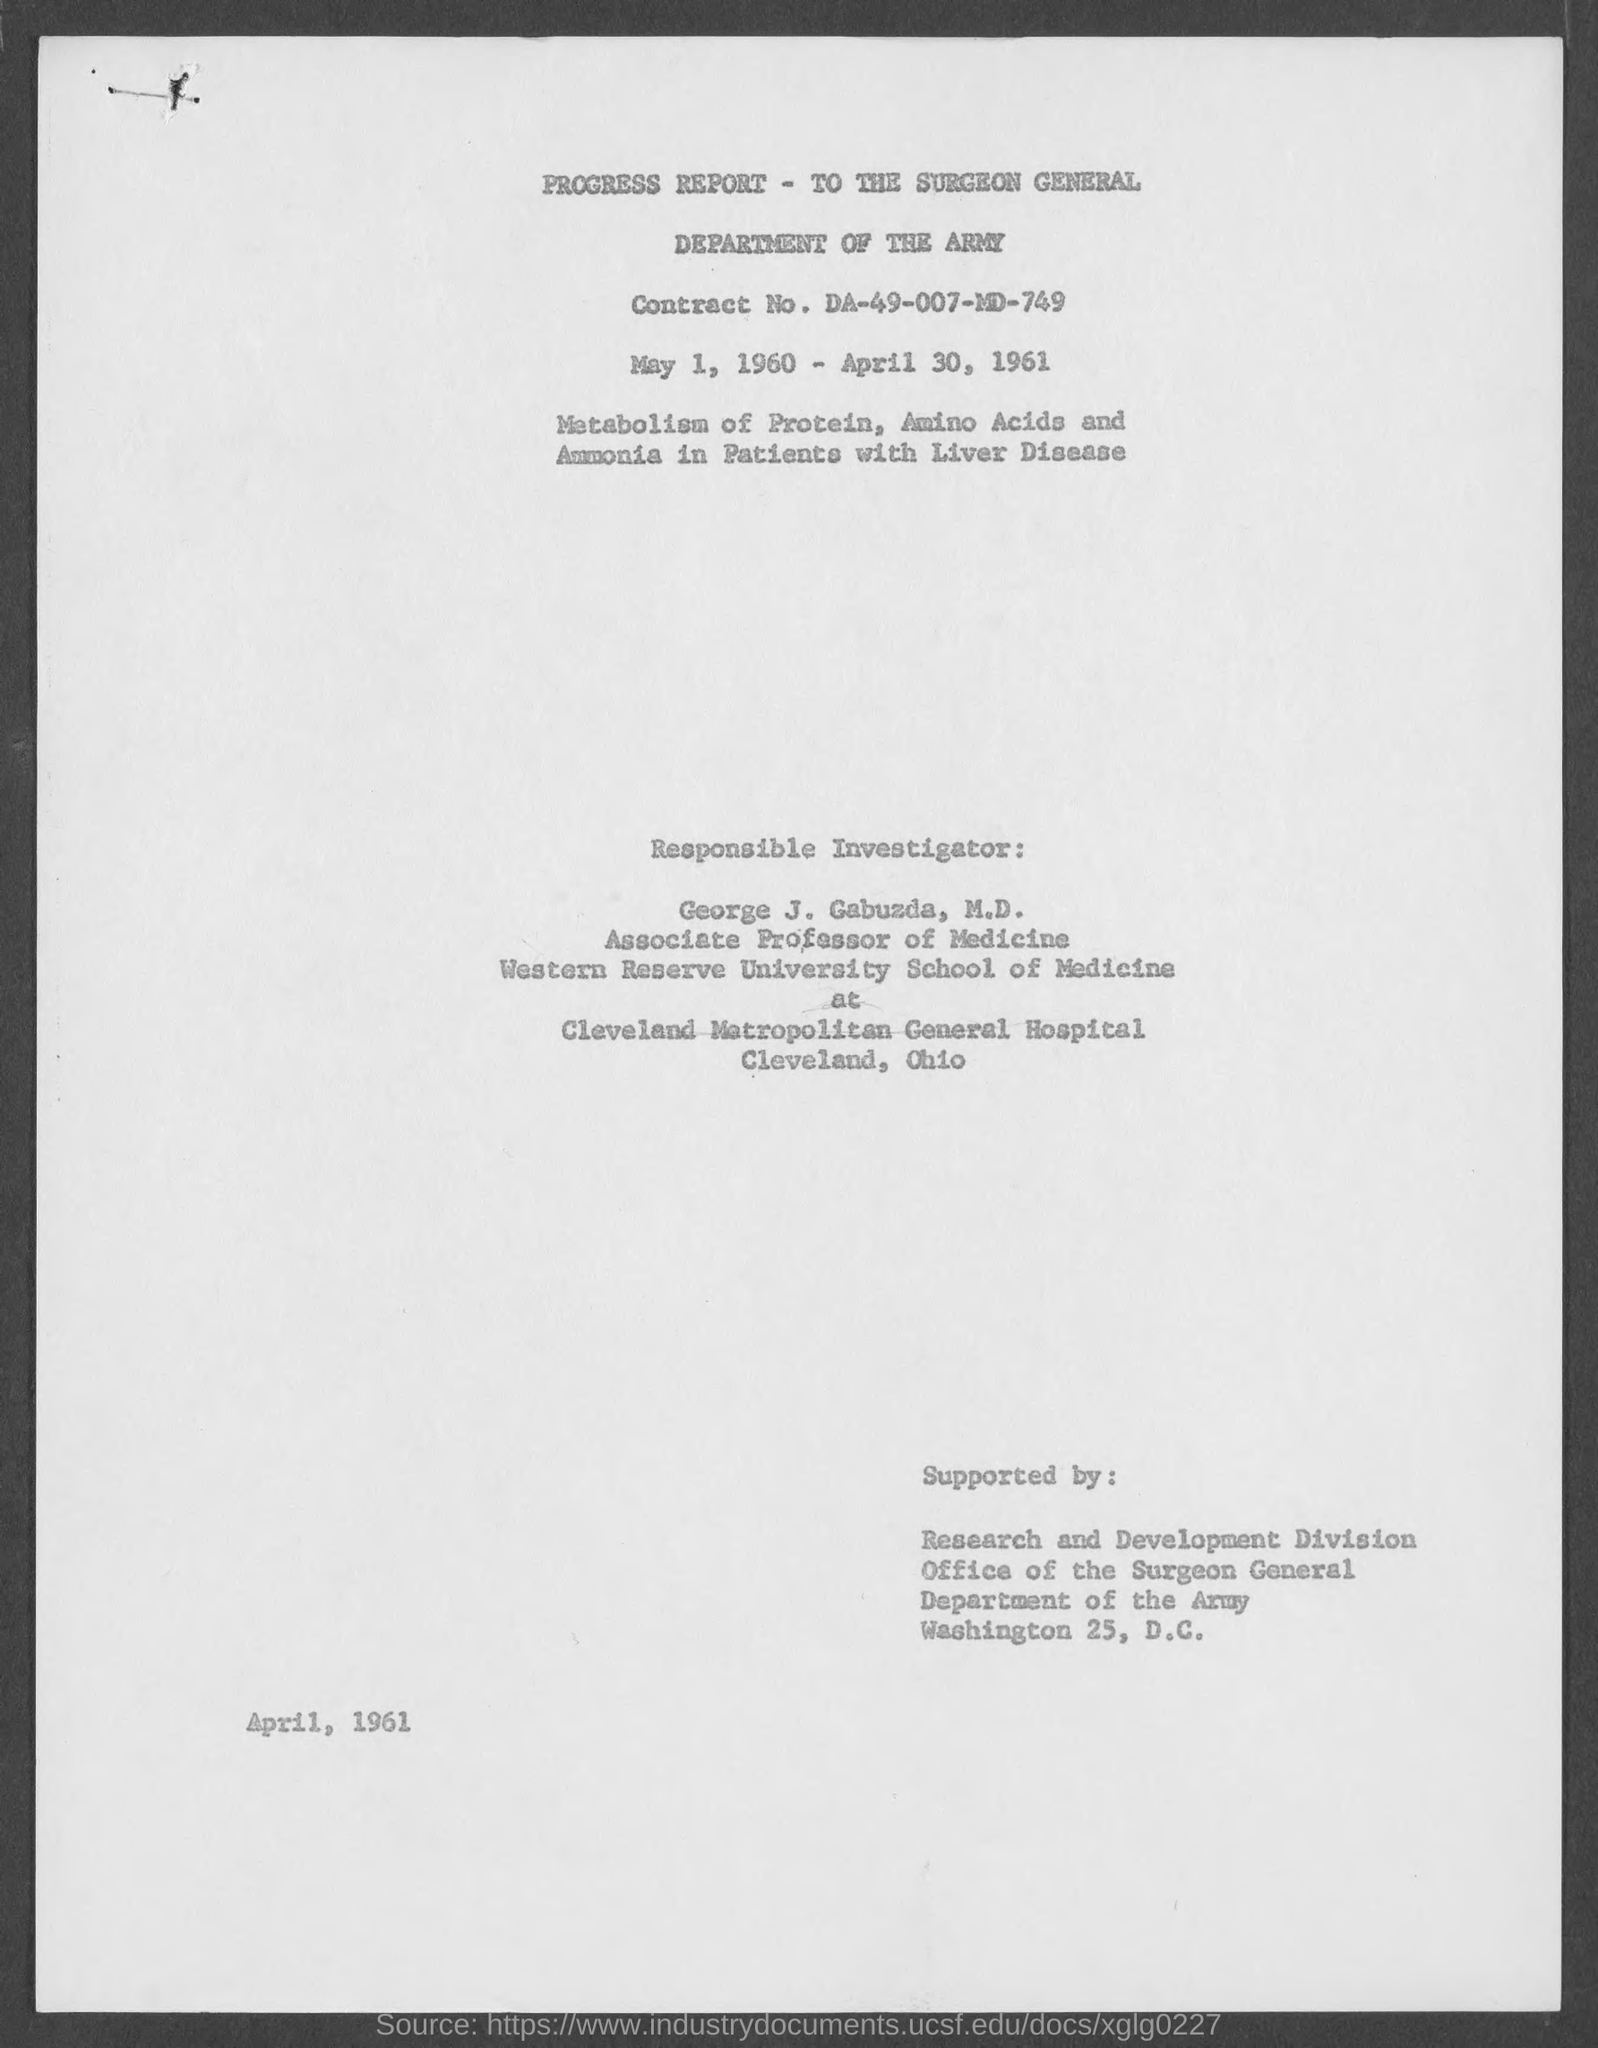Specify some key components in this picture. The document mentions the Department of the Army. The contract number is DA-49-007-MD-749. 